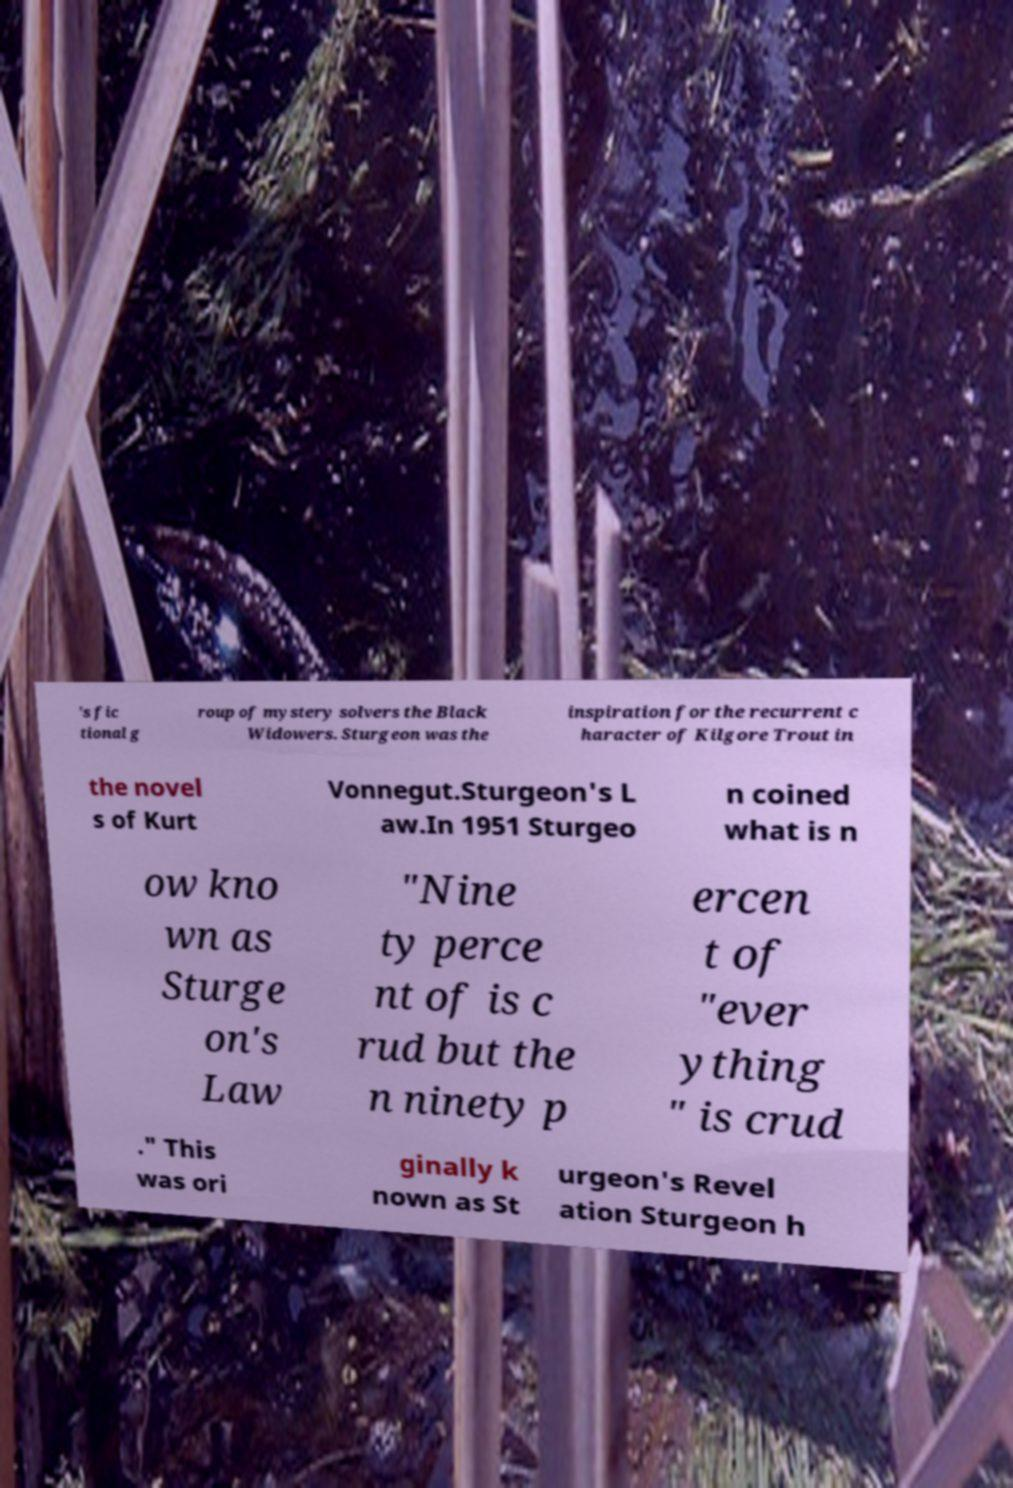Could you assist in decoding the text presented in this image and type it out clearly? 's fic tional g roup of mystery solvers the Black Widowers. Sturgeon was the inspiration for the recurrent c haracter of Kilgore Trout in the novel s of Kurt Vonnegut.Sturgeon's L aw.In 1951 Sturgeo n coined what is n ow kno wn as Sturge on's Law "Nine ty perce nt of is c rud but the n ninety p ercen t of "ever ything " is crud ." This was ori ginally k nown as St urgeon's Revel ation Sturgeon h 